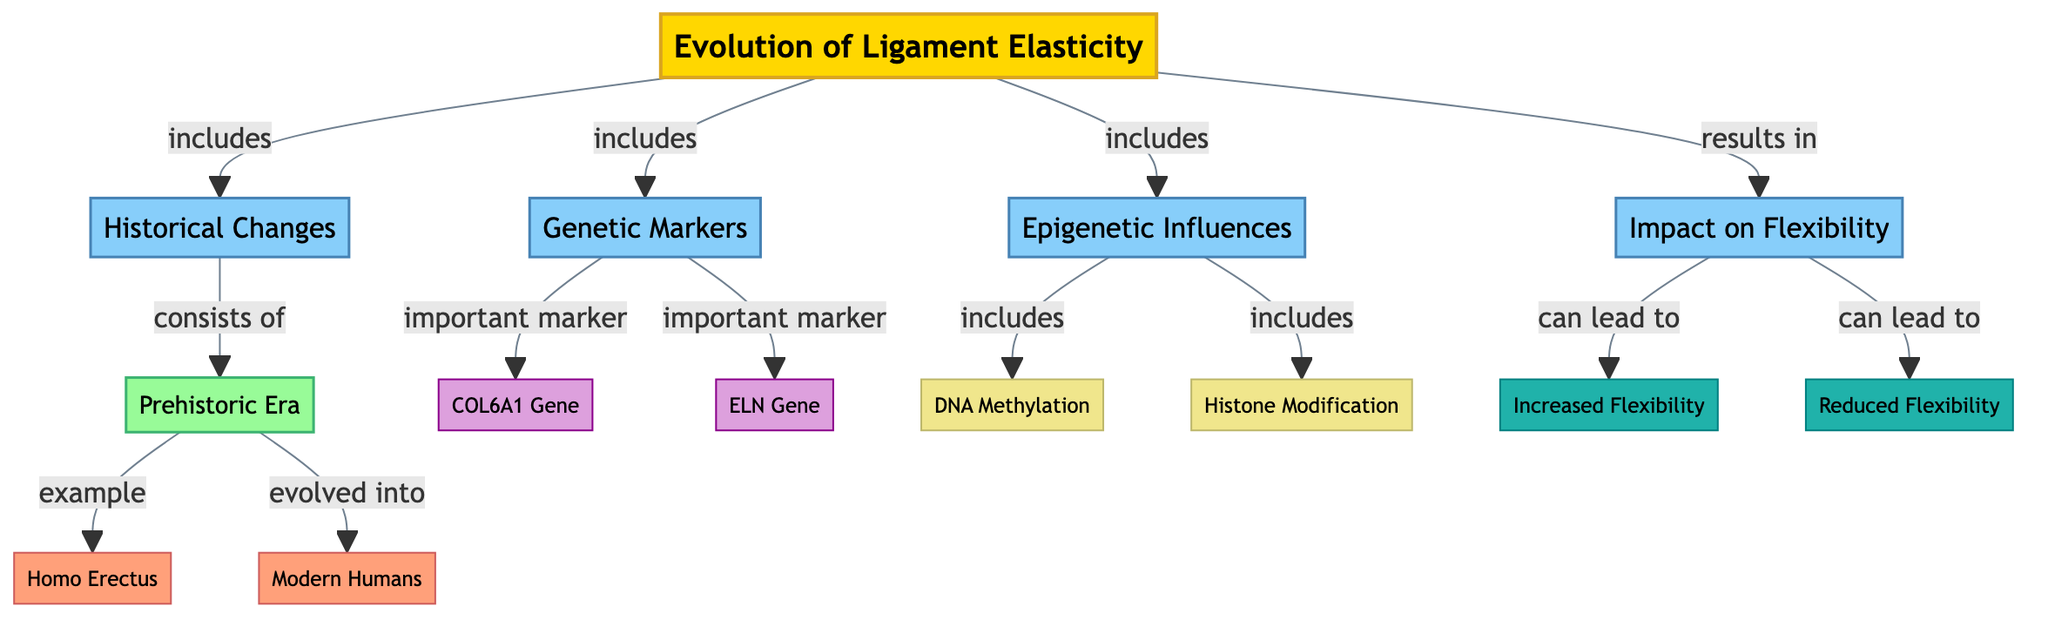What's the title of the diagram? The title is explicitly stated at the top of the diagram as "Evolution of Ligament Elasticity."
Answer: Evolution of Ligament Elasticity What are the two main categories in the diagram? The categories are connected to the title, and they can be found directly below it, labeled as "Historical Changes" and "Genetic Markers."
Answer: Historical Changes, Genetic Markers How many genetic markers are listed in the diagram? The genetic markers can be identified from the "Genetic Markers" category, which contains two entries: "COL6A1 Gene" and "ELN Gene." Counting these gives a total of two genetic markers.
Answer: 2 What process is associated with epigenetic influences on flexibility? The processes listed under the "Epigenetic Influences" category are "DNA Methylation" and "Histone Modification," both of which are indicated in the diagram.
Answer: DNA Methylation, Histone Modification Which human species evolved into modern humans according to the diagram? The diagram connects "Homo Erectus" to "Modern Humans" with an evolutionary relationship, indicating that Homo Erectus evolved into Modern Humans.
Answer: Modern Humans What effect can increased flexibility lead to according to the diagram? The "Impact on Flexibility" category shows the result of increased flexibility, leading to "Increased Flexibility" directly as stated in this section of the diagram.
Answer: Increased Flexibility Which era is specified in the diagram as an example of historical changes? The "Prehistoric Era" is explicitly mentioned under the "Historical Changes" category in the diagram as an example.
Answer: Prehistoric Era What influence is indicated to affect flexibility? The diagram specifies that "Epigenetic Influences" indicated in the category affect flexibility, directly connecting epigenetic factors to the outcome of flexibility in ligaments.
Answer: Epigenetic Influences Which genetic marker is mentioned first in the diagram? The order of the listed genetic markers starts with "COL6A1 Gene," which appears before "ELN Gene" under the "Genetic Markers" category.
Answer: COL6A1 Gene 